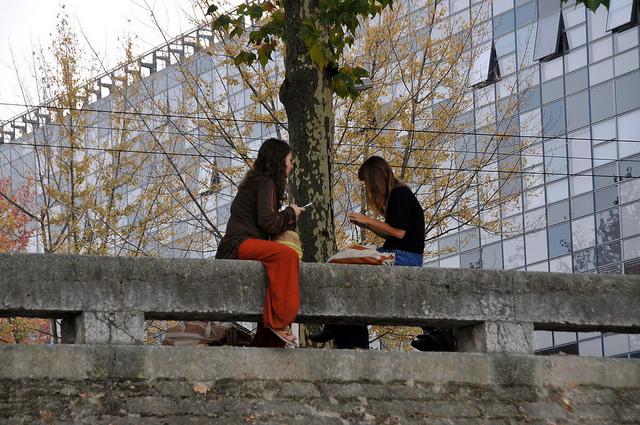Are the women running?
Quick response, please. No. Is the woman looking at the giraffe?
Be succinct. No. Are these people friends?
Short answer required. Yes. How many rows of telephone wires can be seen?
Concise answer only. 3. Who is on the phone?
Be succinct. Woman. 